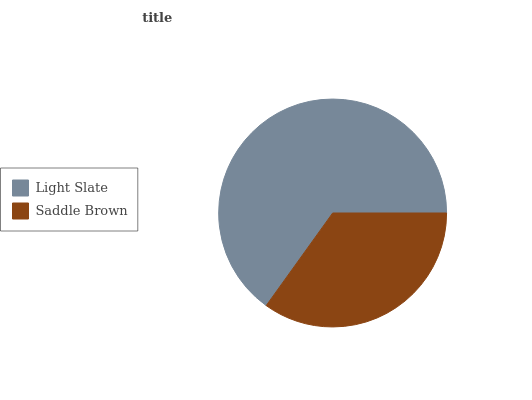Is Saddle Brown the minimum?
Answer yes or no. Yes. Is Light Slate the maximum?
Answer yes or no. Yes. Is Saddle Brown the maximum?
Answer yes or no. No. Is Light Slate greater than Saddle Brown?
Answer yes or no. Yes. Is Saddle Brown less than Light Slate?
Answer yes or no. Yes. Is Saddle Brown greater than Light Slate?
Answer yes or no. No. Is Light Slate less than Saddle Brown?
Answer yes or no. No. Is Light Slate the high median?
Answer yes or no. Yes. Is Saddle Brown the low median?
Answer yes or no. Yes. Is Saddle Brown the high median?
Answer yes or no. No. Is Light Slate the low median?
Answer yes or no. No. 